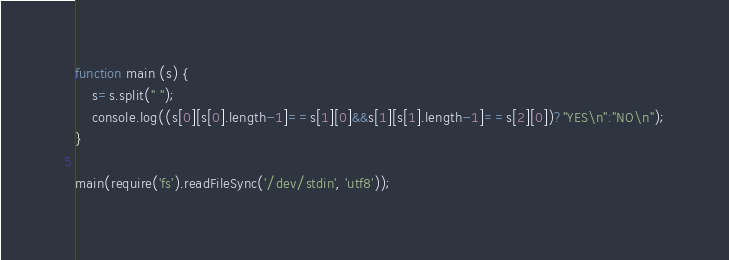<code> <loc_0><loc_0><loc_500><loc_500><_JavaScript_>function main (s) {
    s=s.split(" ");
	console.log((s[0][s[0].length-1]==s[1][0]&&s[1][s[1].length-1]==s[2][0])?"YES\n":"NO\n");
}
 
main(require('fs').readFileSync('/dev/stdin', 'utf8'));</code> 